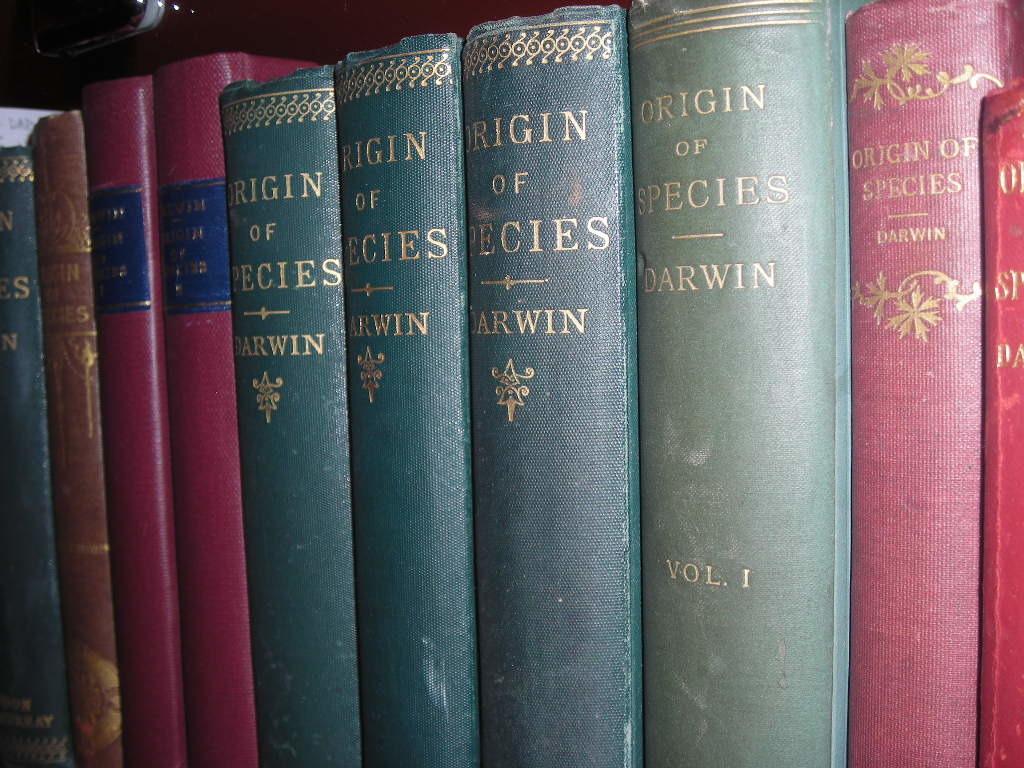Which volume is the green book on the right?
Your answer should be very brief. 1. 